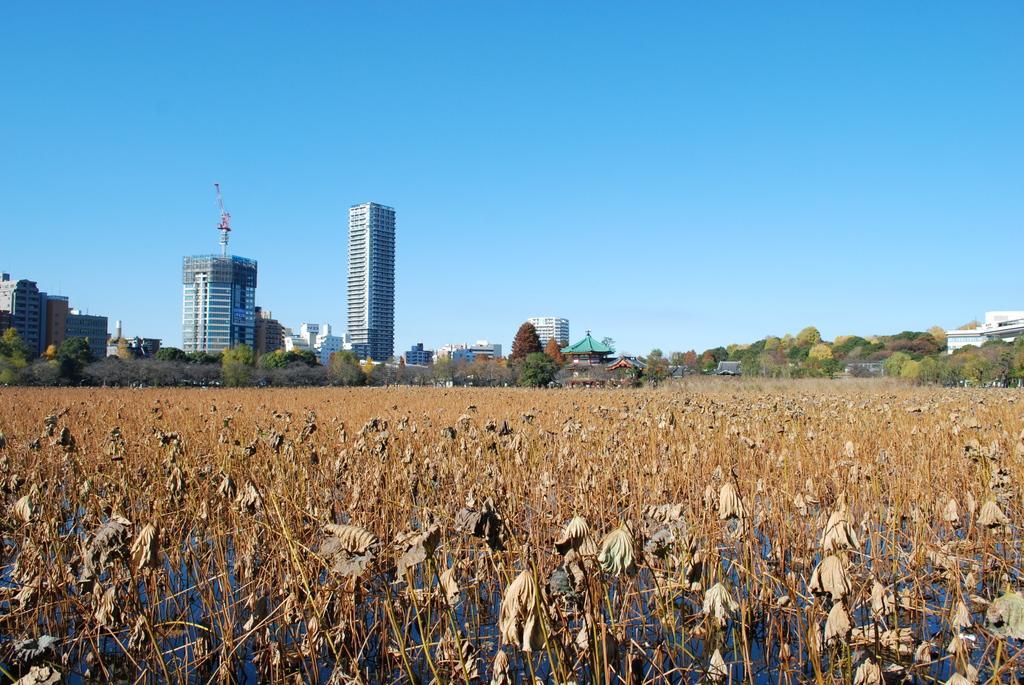Can you describe this image briefly? This image looks like a agricultural land and i can see a dry leaves after few trees a building another building and a small hut after that sky and there is a tower. 